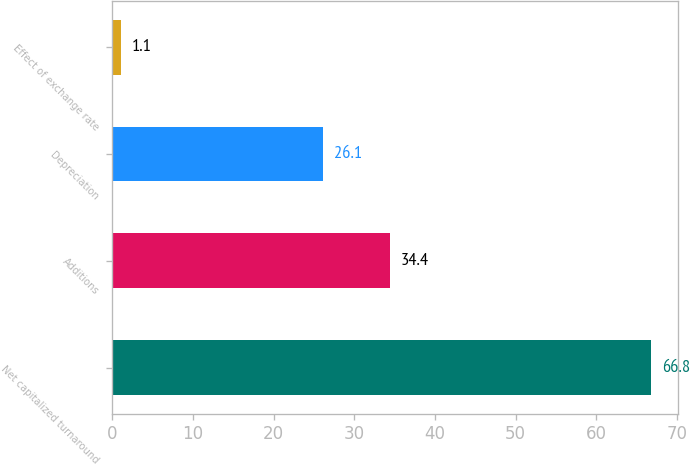Convert chart. <chart><loc_0><loc_0><loc_500><loc_500><bar_chart><fcel>Net capitalized turnaround<fcel>Additions<fcel>Depreciation<fcel>Effect of exchange rate<nl><fcel>66.8<fcel>34.4<fcel>26.1<fcel>1.1<nl></chart> 